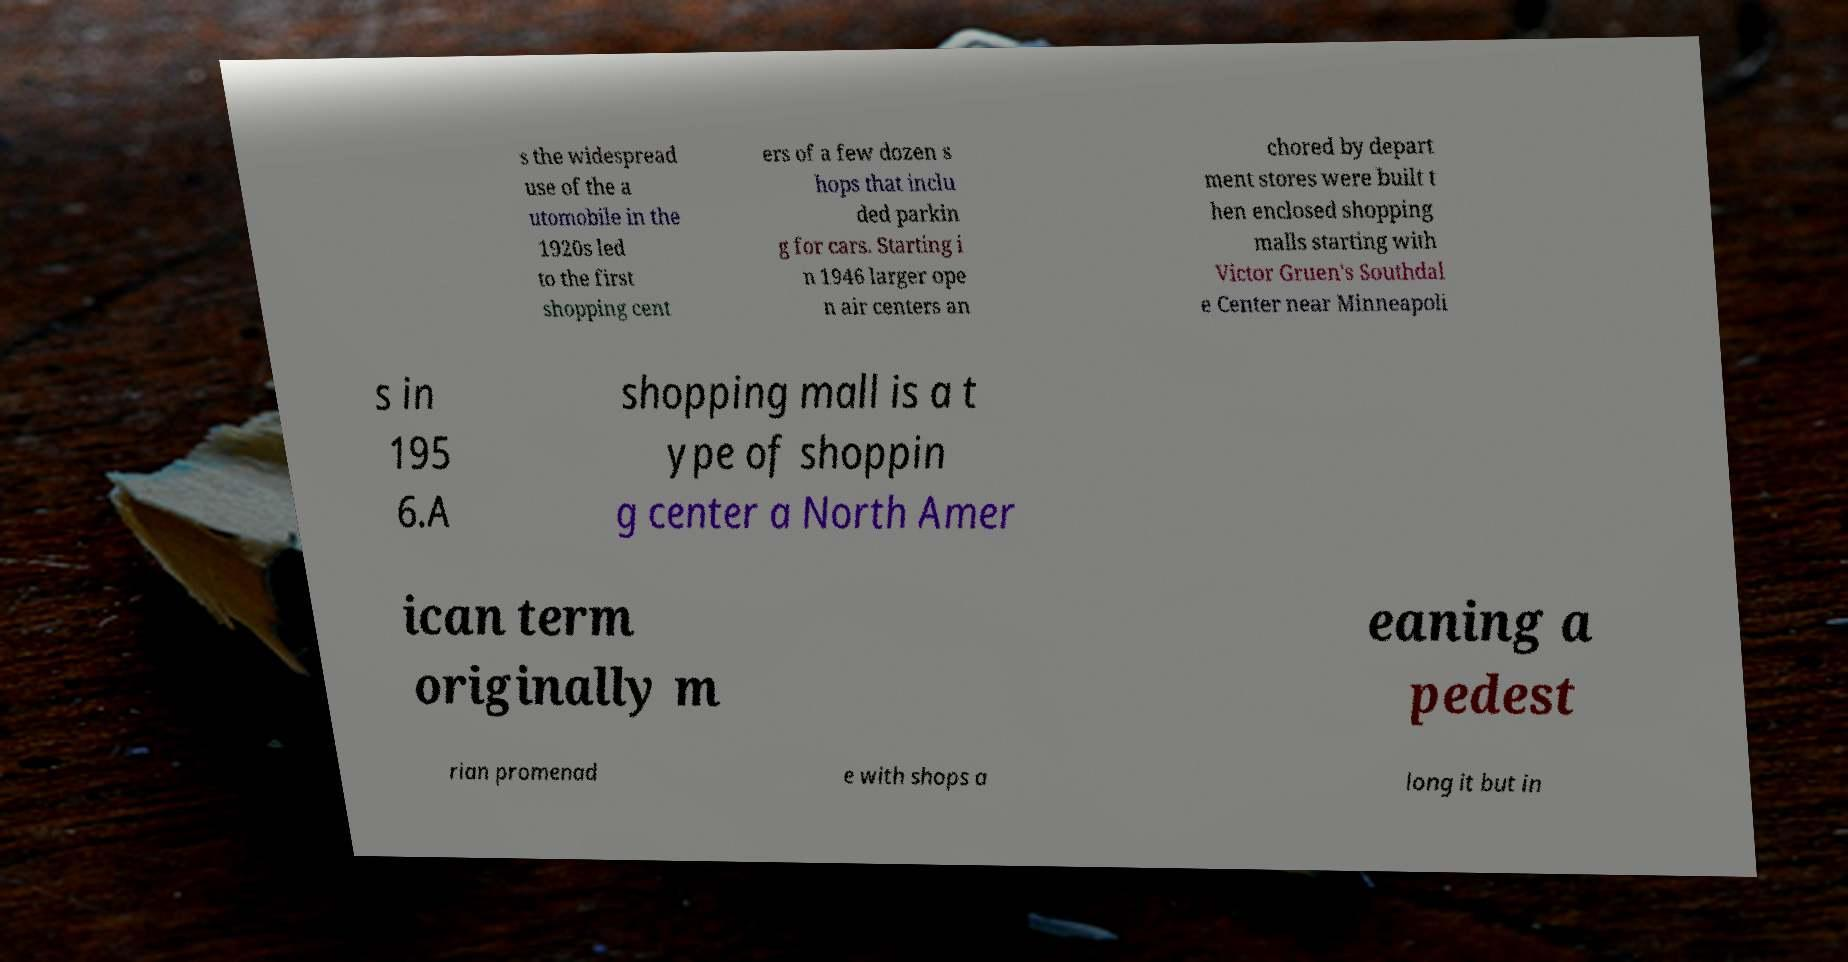Please read and relay the text visible in this image. What does it say? s the widespread use of the a utomobile in the 1920s led to the first shopping cent ers of a few dozen s hops that inclu ded parkin g for cars. Starting i n 1946 larger ope n air centers an chored by depart ment stores were built t hen enclosed shopping malls starting with Victor Gruen's Southdal e Center near Minneapoli s in 195 6.A shopping mall is a t ype of shoppin g center a North Amer ican term originally m eaning a pedest rian promenad e with shops a long it but in 